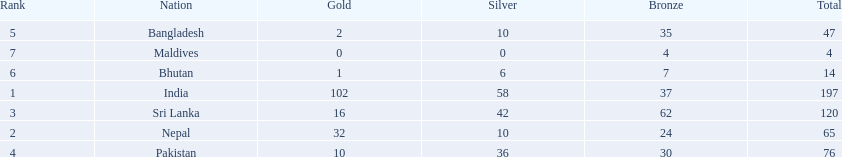How many gold medals were won by the teams? 102, 32, 16, 10, 2, 1, 0. Could you parse the entire table? {'header': ['Rank', 'Nation', 'Gold', 'Silver', 'Bronze', 'Total'], 'rows': [['5', 'Bangladesh', '2', '10', '35', '47'], ['7', 'Maldives', '0', '0', '4', '4'], ['6', 'Bhutan', '1', '6', '7', '14'], ['1', 'India', '102', '58', '37', '197'], ['3', 'Sri Lanka', '16', '42', '62', '120'], ['2', 'Nepal', '32', '10', '24', '65'], ['4', 'Pakistan', '10', '36', '30', '76']]} What country won no gold medals? Maldives. 